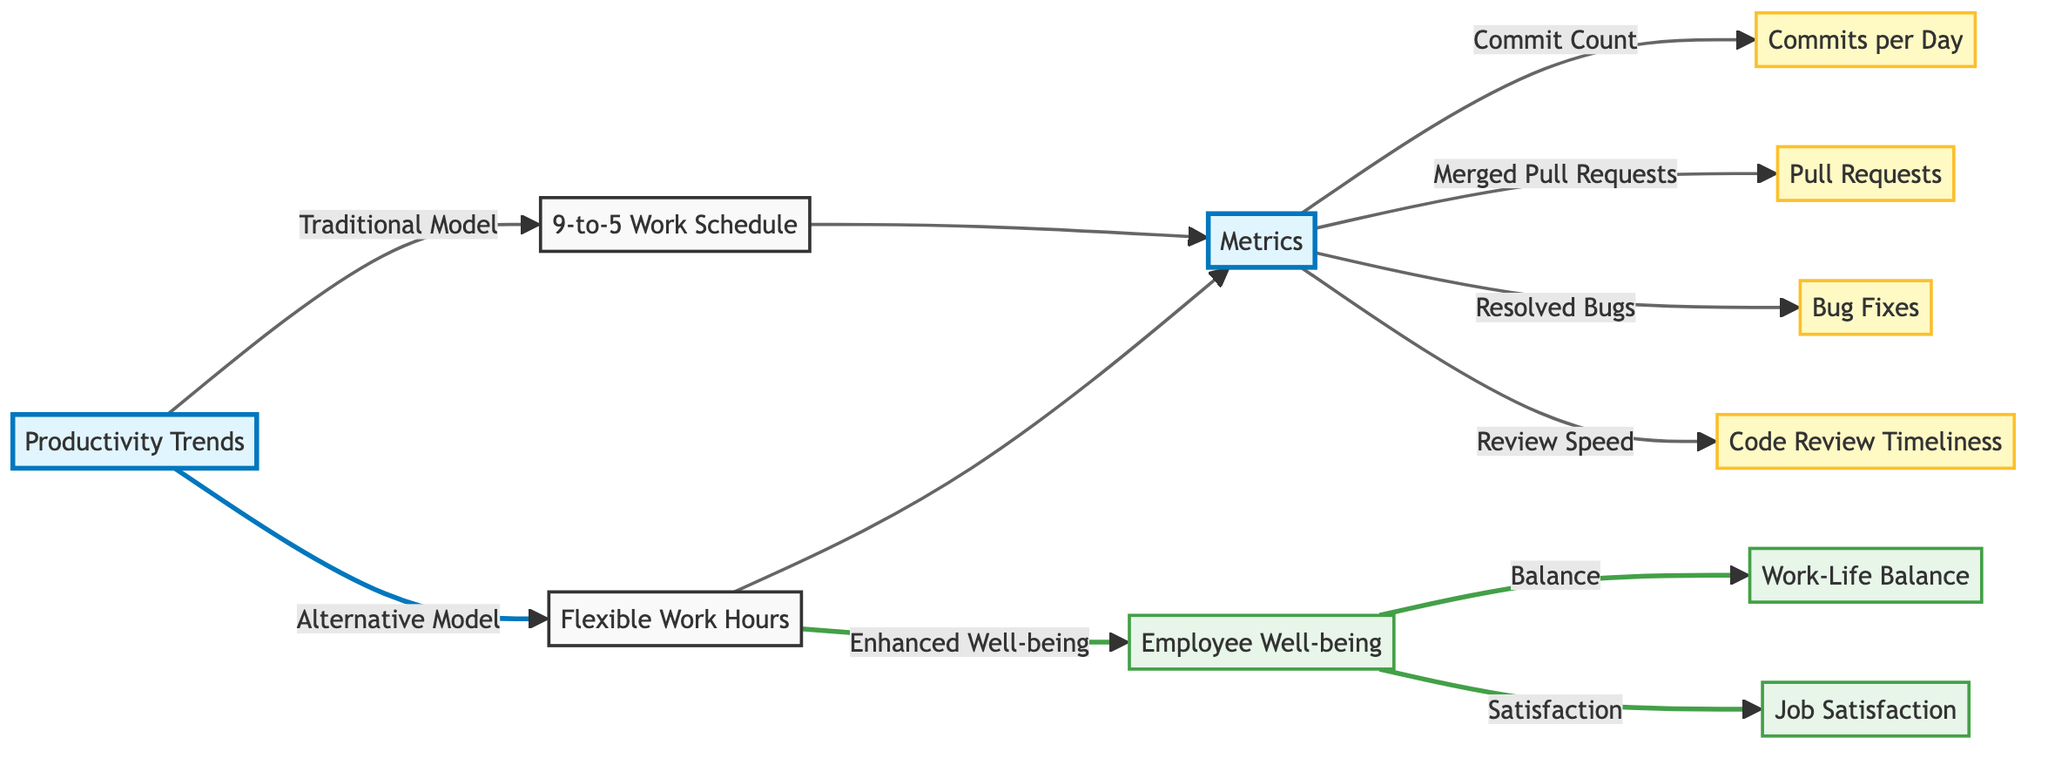What are the two work hour models shown in the diagram? The diagram clearly presents two work hour models: a "9-to-5 Work Schedule" and "Flexible Work Hours." These labels are directly indicated on the nodes corresponding to each model.
Answer: 9-to-5 Work Schedule, Flexible Work Hours How many metrics are associated with both work hour models? The diagram indicates that there are four metrics related to productivity: "Commits per Day," "Pull Requests," "Bug Fixes," and "Code Review Timeliness." These metrics are connected to the node labeled "Metrics."
Answer: 4 Which model is associated with enhanced employee well-being? The "Flexible Work Hours" model has a direct connection to "Enhanced Well-being" in the diagram. This relationship indicates that flexibility in work hours is linked to improved well-being.
Answer: Flexible Work Hours What three outcomes are connected to employee well-being? Employee well-being in the diagram is linked to three outcomes: "Work-Life Balance," "Job Satisfaction," and itself. This establishes a flow from well-being to specific aspects of life quality and satisfaction.
Answer: Work-Life Balance, Job Satisfaction How is the relationship between the traditional model and the alternative model depicted? The diagram shows a branching relationship, where both the "9-to-5 Work Schedule" (traditional) and "Flexible Work Hours" (alternative) connect to the central node "Productivity Trends." This highlights the two different approaches leading to insights about developer output.
Answer: Branching relationship What color style indicates the metrics in the diagram? The metrics are represented by a specific color style labeled as "metricStyle," which is a light yellow. This style is used for the four productivity metrics listed in the diagram.
Answer: Light yellow Which node acts as the primary focus of the diagram? The primary focus of the diagram is represented by the node titled "Productivity Trends." This is the central theme around which the other concepts and data points are organized.
Answer: Productivity Trends Which connection indicates the significance of review speed? The connection labeled "Review Speed" directly leads from the "Metrics" node to "Code Review Timeliness," highlighting it as one of the key productivity indicators in the context of developer output.
Answer: Code Review Timeliness 